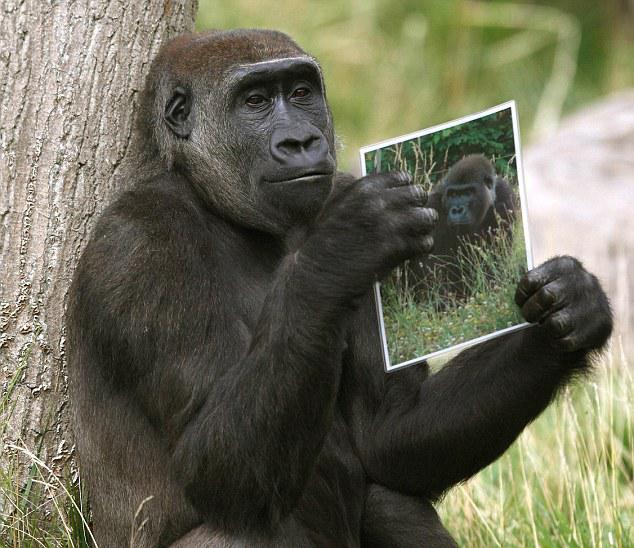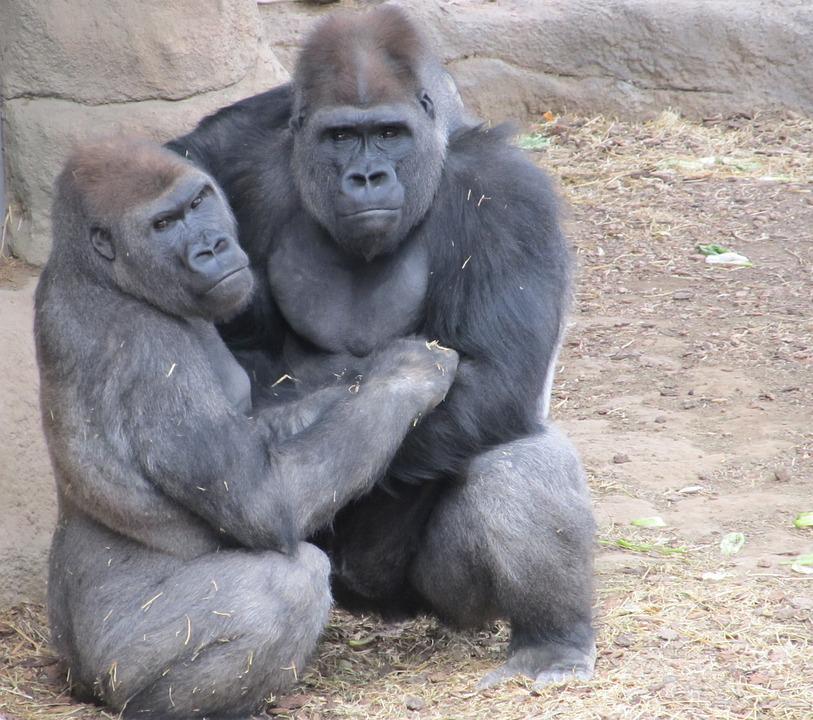The first image is the image on the left, the second image is the image on the right. Given the left and right images, does the statement "There is a single ape holding something in the left image" hold true? Answer yes or no. Yes. The first image is the image on the left, the second image is the image on the right. Considering the images on both sides, is "An image shows exactly one ape, sitting and holding something in its hand." valid? Answer yes or no. Yes. 